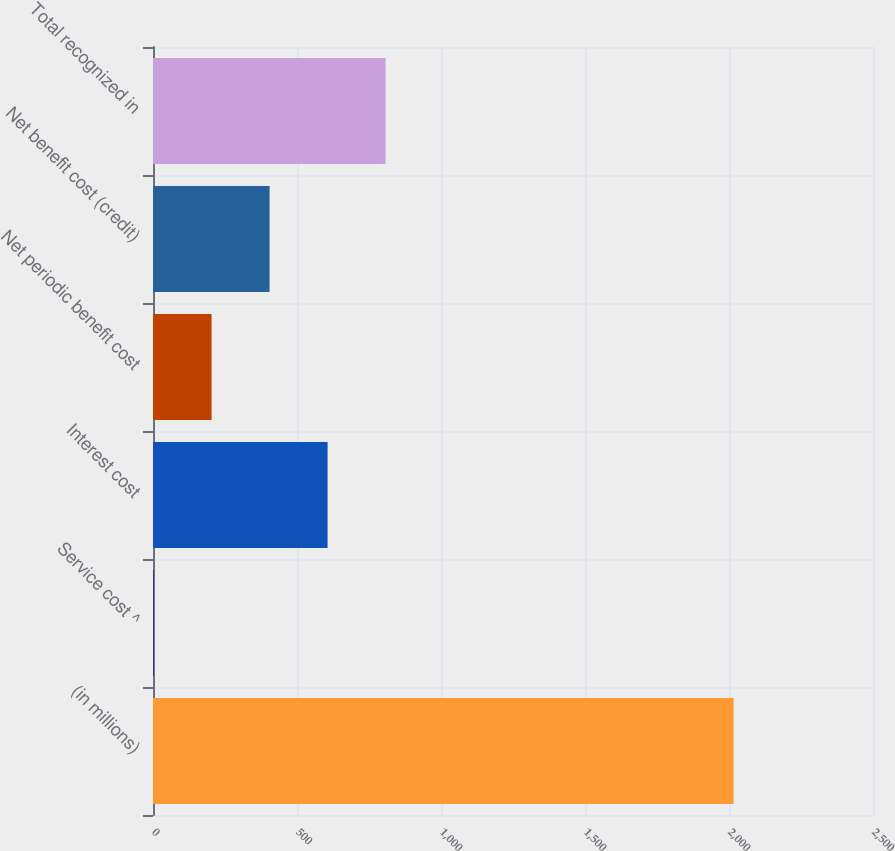Convert chart to OTSL. <chart><loc_0><loc_0><loc_500><loc_500><bar_chart><fcel>(in millions)<fcel>Service cost ^<fcel>Interest cost<fcel>Net periodic benefit cost<fcel>Net benefit cost (credit)<fcel>Total recognized in<nl><fcel>2016<fcel>2<fcel>606.2<fcel>203.4<fcel>404.8<fcel>807.6<nl></chart> 